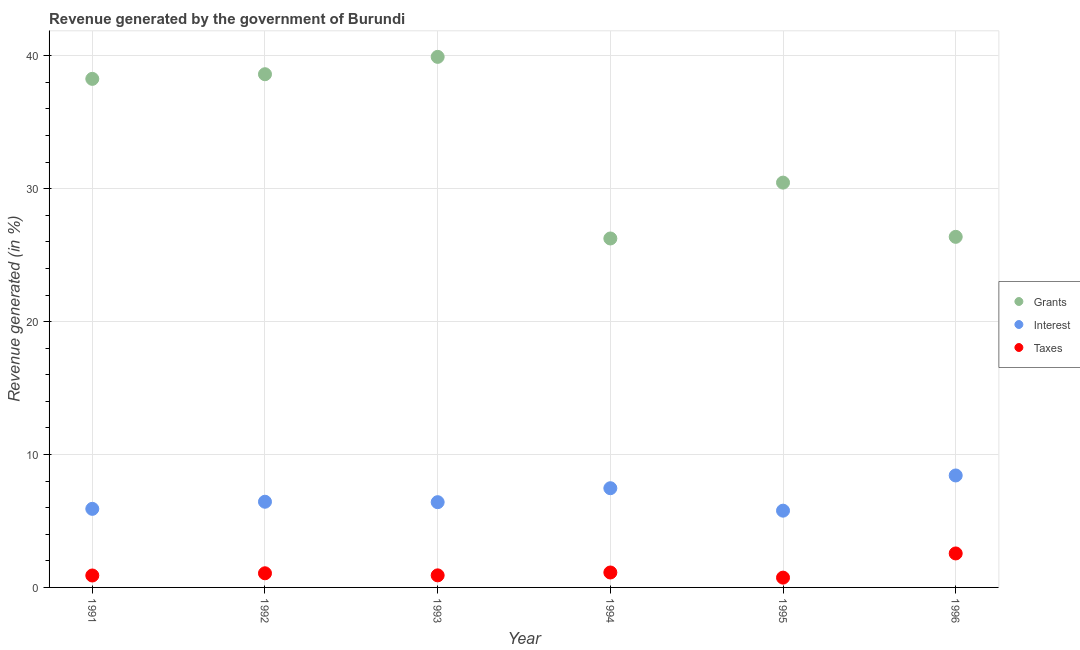How many different coloured dotlines are there?
Offer a terse response. 3. What is the percentage of revenue generated by grants in 1994?
Your answer should be compact. 26.26. Across all years, what is the maximum percentage of revenue generated by taxes?
Give a very brief answer. 2.56. Across all years, what is the minimum percentage of revenue generated by interest?
Offer a terse response. 5.78. What is the total percentage of revenue generated by grants in the graph?
Make the answer very short. 199.89. What is the difference between the percentage of revenue generated by interest in 1995 and that in 1996?
Offer a terse response. -2.65. What is the difference between the percentage of revenue generated by interest in 1993 and the percentage of revenue generated by grants in 1992?
Give a very brief answer. -32.2. What is the average percentage of revenue generated by interest per year?
Provide a short and direct response. 6.74. In the year 1995, what is the difference between the percentage of revenue generated by taxes and percentage of revenue generated by grants?
Your response must be concise. -29.72. What is the ratio of the percentage of revenue generated by taxes in 1993 to that in 1995?
Your answer should be very brief. 1.23. Is the percentage of revenue generated by interest in 1993 less than that in 1995?
Offer a very short reply. No. Is the difference between the percentage of revenue generated by interest in 1991 and 1996 greater than the difference between the percentage of revenue generated by grants in 1991 and 1996?
Offer a very short reply. No. What is the difference between the highest and the second highest percentage of revenue generated by taxes?
Ensure brevity in your answer.  1.43. What is the difference between the highest and the lowest percentage of revenue generated by grants?
Offer a terse response. 13.67. In how many years, is the percentage of revenue generated by grants greater than the average percentage of revenue generated by grants taken over all years?
Make the answer very short. 3. Is the sum of the percentage of revenue generated by grants in 1995 and 1996 greater than the maximum percentage of revenue generated by interest across all years?
Provide a succinct answer. Yes. Is it the case that in every year, the sum of the percentage of revenue generated by grants and percentage of revenue generated by interest is greater than the percentage of revenue generated by taxes?
Your answer should be compact. Yes. Is the percentage of revenue generated by grants strictly less than the percentage of revenue generated by taxes over the years?
Make the answer very short. No. How many years are there in the graph?
Your response must be concise. 6. What is the difference between two consecutive major ticks on the Y-axis?
Your answer should be very brief. 10. Are the values on the major ticks of Y-axis written in scientific E-notation?
Offer a very short reply. No. Does the graph contain grids?
Provide a short and direct response. Yes. What is the title of the graph?
Provide a short and direct response. Revenue generated by the government of Burundi. Does "Labor Market" appear as one of the legend labels in the graph?
Offer a very short reply. No. What is the label or title of the Y-axis?
Your answer should be very brief. Revenue generated (in %). What is the Revenue generated (in %) in Grants in 1991?
Your response must be concise. 38.27. What is the Revenue generated (in %) of Interest in 1991?
Make the answer very short. 5.91. What is the Revenue generated (in %) of Taxes in 1991?
Provide a short and direct response. 0.9. What is the Revenue generated (in %) in Grants in 1992?
Make the answer very short. 38.61. What is the Revenue generated (in %) of Interest in 1992?
Your answer should be very brief. 6.45. What is the Revenue generated (in %) in Taxes in 1992?
Offer a very short reply. 1.06. What is the Revenue generated (in %) of Grants in 1993?
Provide a short and direct response. 39.92. What is the Revenue generated (in %) in Interest in 1993?
Your response must be concise. 6.41. What is the Revenue generated (in %) in Taxes in 1993?
Provide a short and direct response. 0.91. What is the Revenue generated (in %) in Grants in 1994?
Offer a terse response. 26.26. What is the Revenue generated (in %) of Interest in 1994?
Your answer should be compact. 7.47. What is the Revenue generated (in %) in Taxes in 1994?
Your answer should be compact. 1.12. What is the Revenue generated (in %) of Grants in 1995?
Give a very brief answer. 30.46. What is the Revenue generated (in %) of Interest in 1995?
Ensure brevity in your answer.  5.78. What is the Revenue generated (in %) of Taxes in 1995?
Offer a very short reply. 0.74. What is the Revenue generated (in %) of Grants in 1996?
Keep it short and to the point. 26.38. What is the Revenue generated (in %) of Interest in 1996?
Provide a succinct answer. 8.42. What is the Revenue generated (in %) of Taxes in 1996?
Make the answer very short. 2.56. Across all years, what is the maximum Revenue generated (in %) of Grants?
Give a very brief answer. 39.92. Across all years, what is the maximum Revenue generated (in %) in Interest?
Offer a terse response. 8.42. Across all years, what is the maximum Revenue generated (in %) in Taxes?
Offer a very short reply. 2.56. Across all years, what is the minimum Revenue generated (in %) of Grants?
Keep it short and to the point. 26.26. Across all years, what is the minimum Revenue generated (in %) in Interest?
Ensure brevity in your answer.  5.78. Across all years, what is the minimum Revenue generated (in %) in Taxes?
Your response must be concise. 0.74. What is the total Revenue generated (in %) of Grants in the graph?
Your response must be concise. 199.89. What is the total Revenue generated (in %) in Interest in the graph?
Provide a short and direct response. 40.44. What is the total Revenue generated (in %) in Taxes in the graph?
Offer a terse response. 7.29. What is the difference between the Revenue generated (in %) in Grants in 1991 and that in 1992?
Your response must be concise. -0.35. What is the difference between the Revenue generated (in %) in Interest in 1991 and that in 1992?
Provide a succinct answer. -0.53. What is the difference between the Revenue generated (in %) of Grants in 1991 and that in 1993?
Ensure brevity in your answer.  -1.66. What is the difference between the Revenue generated (in %) of Interest in 1991 and that in 1993?
Provide a short and direct response. -0.5. What is the difference between the Revenue generated (in %) of Taxes in 1991 and that in 1993?
Keep it short and to the point. -0.01. What is the difference between the Revenue generated (in %) in Grants in 1991 and that in 1994?
Your answer should be compact. 12.01. What is the difference between the Revenue generated (in %) of Interest in 1991 and that in 1994?
Offer a terse response. -1.55. What is the difference between the Revenue generated (in %) of Taxes in 1991 and that in 1994?
Offer a terse response. -0.23. What is the difference between the Revenue generated (in %) in Grants in 1991 and that in 1995?
Keep it short and to the point. 7.81. What is the difference between the Revenue generated (in %) of Interest in 1991 and that in 1995?
Give a very brief answer. 0.14. What is the difference between the Revenue generated (in %) of Taxes in 1991 and that in 1995?
Keep it short and to the point. 0.16. What is the difference between the Revenue generated (in %) of Grants in 1991 and that in 1996?
Keep it short and to the point. 11.89. What is the difference between the Revenue generated (in %) in Interest in 1991 and that in 1996?
Provide a succinct answer. -2.51. What is the difference between the Revenue generated (in %) of Taxes in 1991 and that in 1996?
Your answer should be compact. -1.66. What is the difference between the Revenue generated (in %) of Grants in 1992 and that in 1993?
Provide a succinct answer. -1.31. What is the difference between the Revenue generated (in %) of Interest in 1992 and that in 1993?
Provide a succinct answer. 0.03. What is the difference between the Revenue generated (in %) in Taxes in 1992 and that in 1993?
Give a very brief answer. 0.16. What is the difference between the Revenue generated (in %) of Grants in 1992 and that in 1994?
Make the answer very short. 12.36. What is the difference between the Revenue generated (in %) of Interest in 1992 and that in 1994?
Offer a very short reply. -1.02. What is the difference between the Revenue generated (in %) of Taxes in 1992 and that in 1994?
Give a very brief answer. -0.06. What is the difference between the Revenue generated (in %) of Grants in 1992 and that in 1995?
Your answer should be very brief. 8.16. What is the difference between the Revenue generated (in %) in Interest in 1992 and that in 1995?
Provide a succinct answer. 0.67. What is the difference between the Revenue generated (in %) of Taxes in 1992 and that in 1995?
Offer a terse response. 0.33. What is the difference between the Revenue generated (in %) of Grants in 1992 and that in 1996?
Ensure brevity in your answer.  12.24. What is the difference between the Revenue generated (in %) in Interest in 1992 and that in 1996?
Ensure brevity in your answer.  -1.98. What is the difference between the Revenue generated (in %) in Taxes in 1992 and that in 1996?
Give a very brief answer. -1.49. What is the difference between the Revenue generated (in %) in Grants in 1993 and that in 1994?
Your answer should be compact. 13.67. What is the difference between the Revenue generated (in %) of Interest in 1993 and that in 1994?
Give a very brief answer. -1.05. What is the difference between the Revenue generated (in %) in Taxes in 1993 and that in 1994?
Your response must be concise. -0.22. What is the difference between the Revenue generated (in %) in Grants in 1993 and that in 1995?
Your answer should be compact. 9.46. What is the difference between the Revenue generated (in %) of Interest in 1993 and that in 1995?
Your answer should be very brief. 0.64. What is the difference between the Revenue generated (in %) in Taxes in 1993 and that in 1995?
Give a very brief answer. 0.17. What is the difference between the Revenue generated (in %) of Grants in 1993 and that in 1996?
Make the answer very short. 13.54. What is the difference between the Revenue generated (in %) in Interest in 1993 and that in 1996?
Your answer should be compact. -2.01. What is the difference between the Revenue generated (in %) of Taxes in 1993 and that in 1996?
Provide a succinct answer. -1.65. What is the difference between the Revenue generated (in %) in Grants in 1994 and that in 1995?
Ensure brevity in your answer.  -4.2. What is the difference between the Revenue generated (in %) in Interest in 1994 and that in 1995?
Offer a terse response. 1.69. What is the difference between the Revenue generated (in %) of Taxes in 1994 and that in 1995?
Provide a short and direct response. 0.39. What is the difference between the Revenue generated (in %) in Grants in 1994 and that in 1996?
Keep it short and to the point. -0.12. What is the difference between the Revenue generated (in %) of Interest in 1994 and that in 1996?
Offer a very short reply. -0.96. What is the difference between the Revenue generated (in %) in Taxes in 1994 and that in 1996?
Make the answer very short. -1.43. What is the difference between the Revenue generated (in %) in Grants in 1995 and that in 1996?
Make the answer very short. 4.08. What is the difference between the Revenue generated (in %) of Interest in 1995 and that in 1996?
Ensure brevity in your answer.  -2.65. What is the difference between the Revenue generated (in %) of Taxes in 1995 and that in 1996?
Provide a short and direct response. -1.82. What is the difference between the Revenue generated (in %) in Grants in 1991 and the Revenue generated (in %) in Interest in 1992?
Offer a terse response. 31.82. What is the difference between the Revenue generated (in %) of Grants in 1991 and the Revenue generated (in %) of Taxes in 1992?
Provide a succinct answer. 37.2. What is the difference between the Revenue generated (in %) in Interest in 1991 and the Revenue generated (in %) in Taxes in 1992?
Offer a very short reply. 4.85. What is the difference between the Revenue generated (in %) of Grants in 1991 and the Revenue generated (in %) of Interest in 1993?
Offer a very short reply. 31.85. What is the difference between the Revenue generated (in %) in Grants in 1991 and the Revenue generated (in %) in Taxes in 1993?
Your answer should be very brief. 37.36. What is the difference between the Revenue generated (in %) in Interest in 1991 and the Revenue generated (in %) in Taxes in 1993?
Offer a very short reply. 5. What is the difference between the Revenue generated (in %) in Grants in 1991 and the Revenue generated (in %) in Interest in 1994?
Make the answer very short. 30.8. What is the difference between the Revenue generated (in %) of Grants in 1991 and the Revenue generated (in %) of Taxes in 1994?
Provide a short and direct response. 37.14. What is the difference between the Revenue generated (in %) in Interest in 1991 and the Revenue generated (in %) in Taxes in 1994?
Give a very brief answer. 4.79. What is the difference between the Revenue generated (in %) of Grants in 1991 and the Revenue generated (in %) of Interest in 1995?
Your answer should be compact. 32.49. What is the difference between the Revenue generated (in %) of Grants in 1991 and the Revenue generated (in %) of Taxes in 1995?
Provide a short and direct response. 37.53. What is the difference between the Revenue generated (in %) in Interest in 1991 and the Revenue generated (in %) in Taxes in 1995?
Keep it short and to the point. 5.18. What is the difference between the Revenue generated (in %) in Grants in 1991 and the Revenue generated (in %) in Interest in 1996?
Ensure brevity in your answer.  29.84. What is the difference between the Revenue generated (in %) in Grants in 1991 and the Revenue generated (in %) in Taxes in 1996?
Keep it short and to the point. 35.71. What is the difference between the Revenue generated (in %) of Interest in 1991 and the Revenue generated (in %) of Taxes in 1996?
Your answer should be very brief. 3.36. What is the difference between the Revenue generated (in %) of Grants in 1992 and the Revenue generated (in %) of Interest in 1993?
Provide a succinct answer. 32.2. What is the difference between the Revenue generated (in %) of Grants in 1992 and the Revenue generated (in %) of Taxes in 1993?
Give a very brief answer. 37.71. What is the difference between the Revenue generated (in %) in Interest in 1992 and the Revenue generated (in %) in Taxes in 1993?
Offer a terse response. 5.54. What is the difference between the Revenue generated (in %) of Grants in 1992 and the Revenue generated (in %) of Interest in 1994?
Make the answer very short. 31.15. What is the difference between the Revenue generated (in %) in Grants in 1992 and the Revenue generated (in %) in Taxes in 1994?
Make the answer very short. 37.49. What is the difference between the Revenue generated (in %) of Interest in 1992 and the Revenue generated (in %) of Taxes in 1994?
Your answer should be very brief. 5.32. What is the difference between the Revenue generated (in %) of Grants in 1992 and the Revenue generated (in %) of Interest in 1995?
Offer a very short reply. 32.84. What is the difference between the Revenue generated (in %) in Grants in 1992 and the Revenue generated (in %) in Taxes in 1995?
Your answer should be very brief. 37.88. What is the difference between the Revenue generated (in %) of Interest in 1992 and the Revenue generated (in %) of Taxes in 1995?
Your answer should be very brief. 5.71. What is the difference between the Revenue generated (in %) in Grants in 1992 and the Revenue generated (in %) in Interest in 1996?
Your answer should be very brief. 30.19. What is the difference between the Revenue generated (in %) in Grants in 1992 and the Revenue generated (in %) in Taxes in 1996?
Provide a succinct answer. 36.06. What is the difference between the Revenue generated (in %) of Interest in 1992 and the Revenue generated (in %) of Taxes in 1996?
Offer a very short reply. 3.89. What is the difference between the Revenue generated (in %) in Grants in 1993 and the Revenue generated (in %) in Interest in 1994?
Your answer should be compact. 32.46. What is the difference between the Revenue generated (in %) of Grants in 1993 and the Revenue generated (in %) of Taxes in 1994?
Make the answer very short. 38.8. What is the difference between the Revenue generated (in %) of Interest in 1993 and the Revenue generated (in %) of Taxes in 1994?
Your response must be concise. 5.29. What is the difference between the Revenue generated (in %) in Grants in 1993 and the Revenue generated (in %) in Interest in 1995?
Your answer should be very brief. 34.15. What is the difference between the Revenue generated (in %) in Grants in 1993 and the Revenue generated (in %) in Taxes in 1995?
Keep it short and to the point. 39.18. What is the difference between the Revenue generated (in %) of Interest in 1993 and the Revenue generated (in %) of Taxes in 1995?
Keep it short and to the point. 5.68. What is the difference between the Revenue generated (in %) of Grants in 1993 and the Revenue generated (in %) of Interest in 1996?
Offer a terse response. 31.5. What is the difference between the Revenue generated (in %) in Grants in 1993 and the Revenue generated (in %) in Taxes in 1996?
Offer a terse response. 37.36. What is the difference between the Revenue generated (in %) in Interest in 1993 and the Revenue generated (in %) in Taxes in 1996?
Give a very brief answer. 3.86. What is the difference between the Revenue generated (in %) in Grants in 1994 and the Revenue generated (in %) in Interest in 1995?
Your answer should be compact. 20.48. What is the difference between the Revenue generated (in %) in Grants in 1994 and the Revenue generated (in %) in Taxes in 1995?
Offer a very short reply. 25.52. What is the difference between the Revenue generated (in %) in Interest in 1994 and the Revenue generated (in %) in Taxes in 1995?
Provide a short and direct response. 6.73. What is the difference between the Revenue generated (in %) of Grants in 1994 and the Revenue generated (in %) of Interest in 1996?
Your answer should be very brief. 17.83. What is the difference between the Revenue generated (in %) in Grants in 1994 and the Revenue generated (in %) in Taxes in 1996?
Your answer should be compact. 23.7. What is the difference between the Revenue generated (in %) in Interest in 1994 and the Revenue generated (in %) in Taxes in 1996?
Ensure brevity in your answer.  4.91. What is the difference between the Revenue generated (in %) in Grants in 1995 and the Revenue generated (in %) in Interest in 1996?
Offer a terse response. 22.03. What is the difference between the Revenue generated (in %) in Grants in 1995 and the Revenue generated (in %) in Taxes in 1996?
Offer a terse response. 27.9. What is the difference between the Revenue generated (in %) of Interest in 1995 and the Revenue generated (in %) of Taxes in 1996?
Make the answer very short. 3.22. What is the average Revenue generated (in %) in Grants per year?
Provide a short and direct response. 33.32. What is the average Revenue generated (in %) in Interest per year?
Offer a terse response. 6.74. What is the average Revenue generated (in %) in Taxes per year?
Provide a succinct answer. 1.21. In the year 1991, what is the difference between the Revenue generated (in %) in Grants and Revenue generated (in %) in Interest?
Offer a very short reply. 32.35. In the year 1991, what is the difference between the Revenue generated (in %) of Grants and Revenue generated (in %) of Taxes?
Your answer should be compact. 37.37. In the year 1991, what is the difference between the Revenue generated (in %) of Interest and Revenue generated (in %) of Taxes?
Ensure brevity in your answer.  5.01. In the year 1992, what is the difference between the Revenue generated (in %) of Grants and Revenue generated (in %) of Interest?
Offer a very short reply. 32.17. In the year 1992, what is the difference between the Revenue generated (in %) in Grants and Revenue generated (in %) in Taxes?
Your answer should be very brief. 37.55. In the year 1992, what is the difference between the Revenue generated (in %) of Interest and Revenue generated (in %) of Taxes?
Make the answer very short. 5.38. In the year 1993, what is the difference between the Revenue generated (in %) of Grants and Revenue generated (in %) of Interest?
Give a very brief answer. 33.51. In the year 1993, what is the difference between the Revenue generated (in %) in Grants and Revenue generated (in %) in Taxes?
Keep it short and to the point. 39.01. In the year 1993, what is the difference between the Revenue generated (in %) in Interest and Revenue generated (in %) in Taxes?
Ensure brevity in your answer.  5.51. In the year 1994, what is the difference between the Revenue generated (in %) in Grants and Revenue generated (in %) in Interest?
Your response must be concise. 18.79. In the year 1994, what is the difference between the Revenue generated (in %) of Grants and Revenue generated (in %) of Taxes?
Keep it short and to the point. 25.13. In the year 1994, what is the difference between the Revenue generated (in %) in Interest and Revenue generated (in %) in Taxes?
Your answer should be very brief. 6.34. In the year 1995, what is the difference between the Revenue generated (in %) of Grants and Revenue generated (in %) of Interest?
Provide a short and direct response. 24.68. In the year 1995, what is the difference between the Revenue generated (in %) in Grants and Revenue generated (in %) in Taxes?
Make the answer very short. 29.72. In the year 1995, what is the difference between the Revenue generated (in %) in Interest and Revenue generated (in %) in Taxes?
Your answer should be compact. 5.04. In the year 1996, what is the difference between the Revenue generated (in %) of Grants and Revenue generated (in %) of Interest?
Make the answer very short. 17.95. In the year 1996, what is the difference between the Revenue generated (in %) in Grants and Revenue generated (in %) in Taxes?
Your response must be concise. 23.82. In the year 1996, what is the difference between the Revenue generated (in %) of Interest and Revenue generated (in %) of Taxes?
Provide a short and direct response. 5.87. What is the ratio of the Revenue generated (in %) of Interest in 1991 to that in 1992?
Provide a short and direct response. 0.92. What is the ratio of the Revenue generated (in %) in Taxes in 1991 to that in 1992?
Your answer should be compact. 0.84. What is the ratio of the Revenue generated (in %) of Grants in 1991 to that in 1993?
Your answer should be compact. 0.96. What is the ratio of the Revenue generated (in %) in Interest in 1991 to that in 1993?
Offer a very short reply. 0.92. What is the ratio of the Revenue generated (in %) of Taxes in 1991 to that in 1993?
Provide a succinct answer. 0.99. What is the ratio of the Revenue generated (in %) of Grants in 1991 to that in 1994?
Make the answer very short. 1.46. What is the ratio of the Revenue generated (in %) in Interest in 1991 to that in 1994?
Make the answer very short. 0.79. What is the ratio of the Revenue generated (in %) of Taxes in 1991 to that in 1994?
Offer a very short reply. 0.8. What is the ratio of the Revenue generated (in %) of Grants in 1991 to that in 1995?
Keep it short and to the point. 1.26. What is the ratio of the Revenue generated (in %) of Interest in 1991 to that in 1995?
Your response must be concise. 1.02. What is the ratio of the Revenue generated (in %) of Taxes in 1991 to that in 1995?
Your answer should be very brief. 1.22. What is the ratio of the Revenue generated (in %) in Grants in 1991 to that in 1996?
Your answer should be compact. 1.45. What is the ratio of the Revenue generated (in %) in Interest in 1991 to that in 1996?
Make the answer very short. 0.7. What is the ratio of the Revenue generated (in %) in Taxes in 1991 to that in 1996?
Your answer should be very brief. 0.35. What is the ratio of the Revenue generated (in %) of Grants in 1992 to that in 1993?
Give a very brief answer. 0.97. What is the ratio of the Revenue generated (in %) of Taxes in 1992 to that in 1993?
Provide a short and direct response. 1.17. What is the ratio of the Revenue generated (in %) of Grants in 1992 to that in 1994?
Offer a terse response. 1.47. What is the ratio of the Revenue generated (in %) of Interest in 1992 to that in 1994?
Ensure brevity in your answer.  0.86. What is the ratio of the Revenue generated (in %) of Taxes in 1992 to that in 1994?
Your answer should be very brief. 0.95. What is the ratio of the Revenue generated (in %) in Grants in 1992 to that in 1995?
Provide a succinct answer. 1.27. What is the ratio of the Revenue generated (in %) of Interest in 1992 to that in 1995?
Make the answer very short. 1.12. What is the ratio of the Revenue generated (in %) in Taxes in 1992 to that in 1995?
Offer a very short reply. 1.44. What is the ratio of the Revenue generated (in %) of Grants in 1992 to that in 1996?
Provide a short and direct response. 1.46. What is the ratio of the Revenue generated (in %) of Interest in 1992 to that in 1996?
Provide a short and direct response. 0.77. What is the ratio of the Revenue generated (in %) of Taxes in 1992 to that in 1996?
Give a very brief answer. 0.42. What is the ratio of the Revenue generated (in %) in Grants in 1993 to that in 1994?
Offer a terse response. 1.52. What is the ratio of the Revenue generated (in %) of Interest in 1993 to that in 1994?
Ensure brevity in your answer.  0.86. What is the ratio of the Revenue generated (in %) in Taxes in 1993 to that in 1994?
Offer a very short reply. 0.81. What is the ratio of the Revenue generated (in %) in Grants in 1993 to that in 1995?
Provide a short and direct response. 1.31. What is the ratio of the Revenue generated (in %) in Interest in 1993 to that in 1995?
Ensure brevity in your answer.  1.11. What is the ratio of the Revenue generated (in %) in Taxes in 1993 to that in 1995?
Offer a very short reply. 1.23. What is the ratio of the Revenue generated (in %) in Grants in 1993 to that in 1996?
Ensure brevity in your answer.  1.51. What is the ratio of the Revenue generated (in %) of Interest in 1993 to that in 1996?
Your answer should be compact. 0.76. What is the ratio of the Revenue generated (in %) in Taxes in 1993 to that in 1996?
Give a very brief answer. 0.36. What is the ratio of the Revenue generated (in %) of Grants in 1994 to that in 1995?
Offer a very short reply. 0.86. What is the ratio of the Revenue generated (in %) in Interest in 1994 to that in 1995?
Your response must be concise. 1.29. What is the ratio of the Revenue generated (in %) of Taxes in 1994 to that in 1995?
Your response must be concise. 1.52. What is the ratio of the Revenue generated (in %) in Interest in 1994 to that in 1996?
Your answer should be compact. 0.89. What is the ratio of the Revenue generated (in %) of Taxes in 1994 to that in 1996?
Provide a succinct answer. 0.44. What is the ratio of the Revenue generated (in %) in Grants in 1995 to that in 1996?
Make the answer very short. 1.15. What is the ratio of the Revenue generated (in %) of Interest in 1995 to that in 1996?
Ensure brevity in your answer.  0.69. What is the ratio of the Revenue generated (in %) in Taxes in 1995 to that in 1996?
Your answer should be compact. 0.29. What is the difference between the highest and the second highest Revenue generated (in %) of Grants?
Your answer should be very brief. 1.31. What is the difference between the highest and the second highest Revenue generated (in %) of Interest?
Your answer should be compact. 0.96. What is the difference between the highest and the second highest Revenue generated (in %) of Taxes?
Offer a terse response. 1.43. What is the difference between the highest and the lowest Revenue generated (in %) in Grants?
Your response must be concise. 13.67. What is the difference between the highest and the lowest Revenue generated (in %) in Interest?
Give a very brief answer. 2.65. What is the difference between the highest and the lowest Revenue generated (in %) in Taxes?
Your answer should be compact. 1.82. 